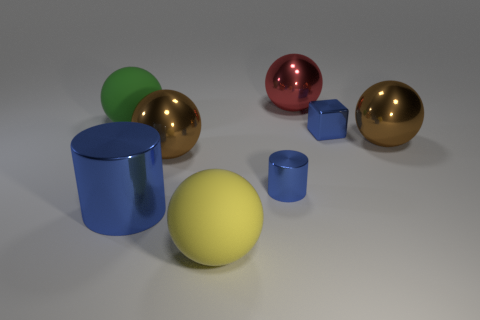Are there fewer large spheres that are in front of the green thing than blue metallic cylinders?
Offer a very short reply. No. The yellow object that is the same size as the green matte ball is what shape?
Give a very brief answer. Sphere. How many other objects are there of the same color as the tiny metallic cube?
Offer a terse response. 2. Do the red shiny object and the yellow matte sphere have the same size?
Keep it short and to the point. Yes. What number of things are either small shiny cubes or big brown things that are to the left of the large red ball?
Your response must be concise. 2. Are there fewer things that are in front of the small cylinder than large yellow things in front of the big yellow rubber object?
Make the answer very short. No. What number of other objects are there of the same material as the big cylinder?
Your response must be concise. 5. Do the big matte sphere behind the yellow rubber object and the big cylinder have the same color?
Your answer should be compact. No. There is a ball on the right side of the cube; is there a large matte object in front of it?
Offer a terse response. Yes. There is a sphere that is both right of the yellow rubber sphere and in front of the small metallic block; what is its material?
Your answer should be very brief. Metal. 